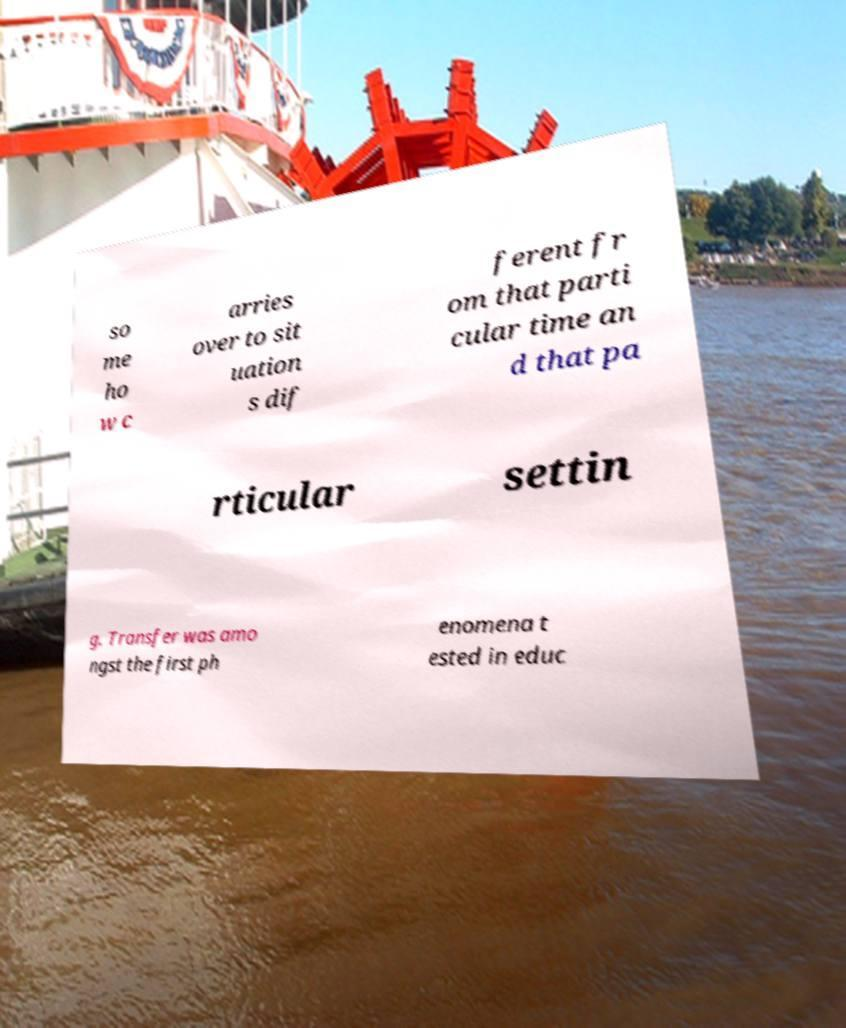Please identify and transcribe the text found in this image. so me ho w c arries over to sit uation s dif ferent fr om that parti cular time an d that pa rticular settin g. Transfer was amo ngst the first ph enomena t ested in educ 